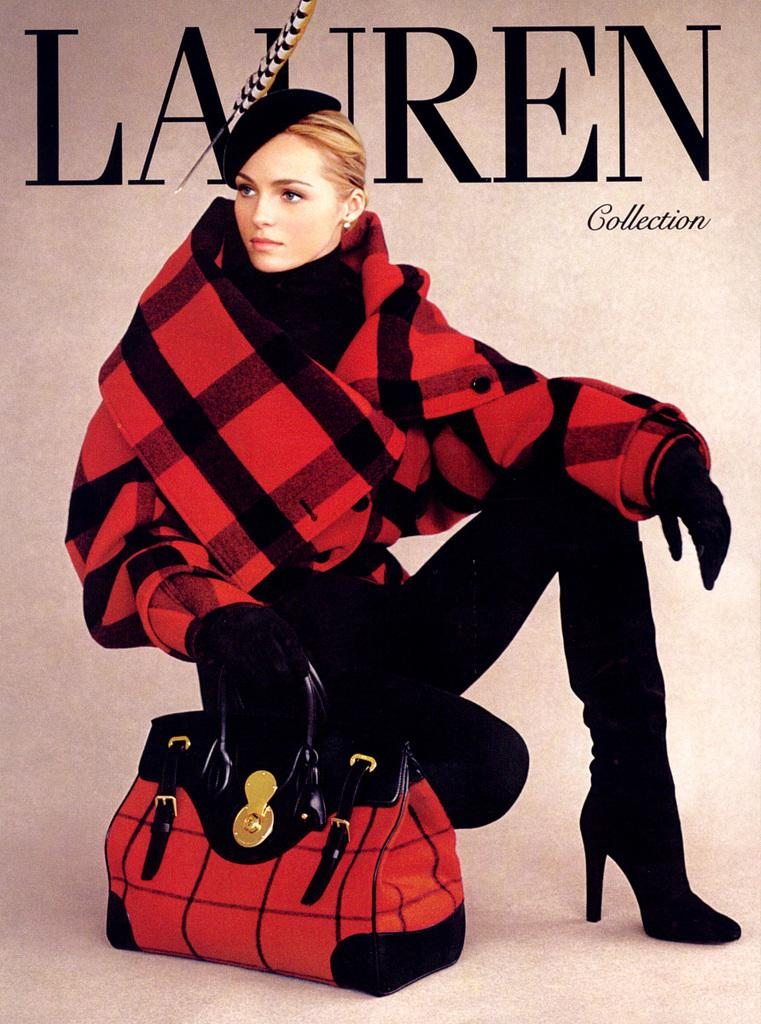Who is the main subject in the image? There is a lady in the image. What colors is the lady wearing? The lady is wearing black and red colors. What is the lady holding in the image? The lady is holding a bag. What is the color of the bag? The bag is black and red in color. Is the lady crying or showing any signs of distress in the image? There is no indication in the image that the lady is crying or showing any signs of distress. Does the lady have a pet with her in the image? There is no pet visible in the image. 